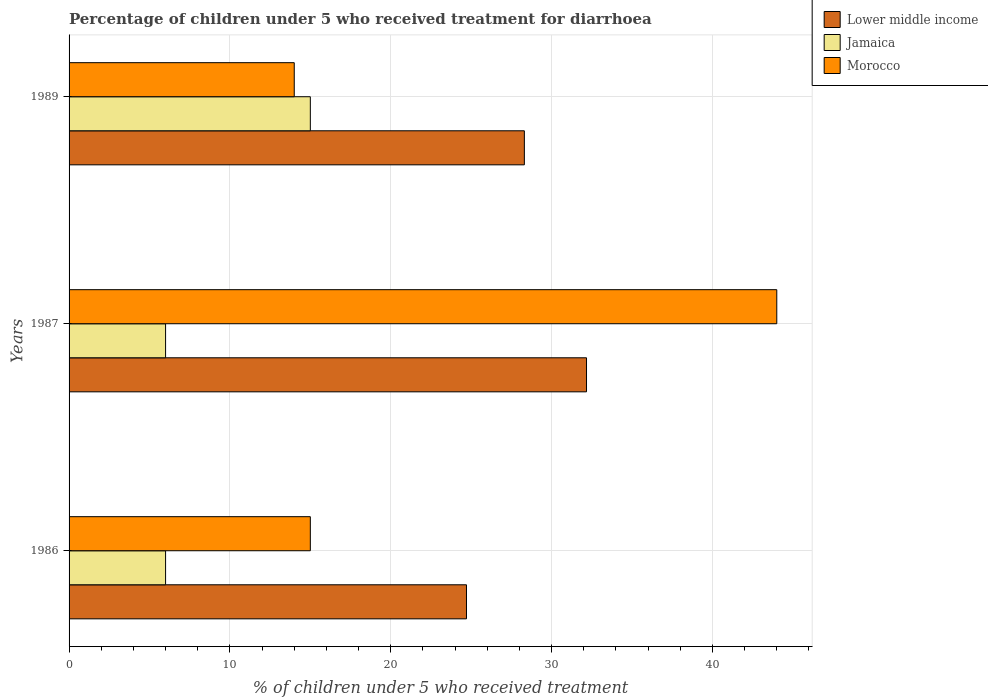How many different coloured bars are there?
Give a very brief answer. 3. How many groups of bars are there?
Provide a short and direct response. 3. Are the number of bars per tick equal to the number of legend labels?
Your answer should be compact. Yes. How many bars are there on the 1st tick from the top?
Provide a short and direct response. 3. In how many cases, is the number of bars for a given year not equal to the number of legend labels?
Offer a very short reply. 0. Across all years, what is the minimum percentage of children who received treatment for diarrhoea  in Morocco?
Your response must be concise. 14. In which year was the percentage of children who received treatment for diarrhoea  in Jamaica maximum?
Give a very brief answer. 1989. What is the total percentage of children who received treatment for diarrhoea  in Lower middle income in the graph?
Ensure brevity in your answer.  85.19. What is the difference between the percentage of children who received treatment for diarrhoea  in Jamaica in 1986 and that in 1987?
Ensure brevity in your answer.  0. What is the difference between the percentage of children who received treatment for diarrhoea  in Jamaica in 1987 and the percentage of children who received treatment for diarrhoea  in Lower middle income in 1989?
Provide a succinct answer. -22.31. What is the average percentage of children who received treatment for diarrhoea  in Lower middle income per year?
Keep it short and to the point. 28.4. In the year 1986, what is the difference between the percentage of children who received treatment for diarrhoea  in Lower middle income and percentage of children who received treatment for diarrhoea  in Morocco?
Offer a very short reply. 9.71. What is the ratio of the percentage of children who received treatment for diarrhoea  in Lower middle income in 1987 to that in 1989?
Your answer should be compact. 1.14. Is the percentage of children who received treatment for diarrhoea  in Lower middle income in 1987 less than that in 1989?
Make the answer very short. No. Is the difference between the percentage of children who received treatment for diarrhoea  in Lower middle income in 1986 and 1987 greater than the difference between the percentage of children who received treatment for diarrhoea  in Morocco in 1986 and 1987?
Provide a succinct answer. Yes. What is the difference between the highest and the second highest percentage of children who received treatment for diarrhoea  in Lower middle income?
Provide a succinct answer. 3.86. What is the difference between the highest and the lowest percentage of children who received treatment for diarrhoea  in Lower middle income?
Make the answer very short. 7.46. In how many years, is the percentage of children who received treatment for diarrhoea  in Lower middle income greater than the average percentage of children who received treatment for diarrhoea  in Lower middle income taken over all years?
Ensure brevity in your answer.  1. What does the 3rd bar from the top in 1989 represents?
Your answer should be compact. Lower middle income. What does the 1st bar from the bottom in 1986 represents?
Your response must be concise. Lower middle income. Is it the case that in every year, the sum of the percentage of children who received treatment for diarrhoea  in Lower middle income and percentage of children who received treatment for diarrhoea  in Jamaica is greater than the percentage of children who received treatment for diarrhoea  in Morocco?
Offer a very short reply. No. How many bars are there?
Offer a very short reply. 9. What is the difference between two consecutive major ticks on the X-axis?
Your answer should be compact. 10. Does the graph contain any zero values?
Offer a terse response. No. Does the graph contain grids?
Give a very brief answer. Yes. What is the title of the graph?
Keep it short and to the point. Percentage of children under 5 who received treatment for diarrhoea. What is the label or title of the X-axis?
Provide a succinct answer. % of children under 5 who received treatment. What is the % of children under 5 who received treatment of Lower middle income in 1986?
Your answer should be very brief. 24.71. What is the % of children under 5 who received treatment in Jamaica in 1986?
Give a very brief answer. 6. What is the % of children under 5 who received treatment of Lower middle income in 1987?
Your response must be concise. 32.17. What is the % of children under 5 who received treatment in Jamaica in 1987?
Your response must be concise. 6. What is the % of children under 5 who received treatment in Lower middle income in 1989?
Make the answer very short. 28.31. What is the % of children under 5 who received treatment of Morocco in 1989?
Your answer should be compact. 14. Across all years, what is the maximum % of children under 5 who received treatment of Lower middle income?
Your answer should be very brief. 32.17. Across all years, what is the maximum % of children under 5 who received treatment in Jamaica?
Your answer should be compact. 15. Across all years, what is the minimum % of children under 5 who received treatment of Lower middle income?
Give a very brief answer. 24.71. What is the total % of children under 5 who received treatment of Lower middle income in the graph?
Offer a terse response. 85.19. What is the total % of children under 5 who received treatment of Jamaica in the graph?
Your response must be concise. 27. What is the total % of children under 5 who received treatment in Morocco in the graph?
Your answer should be compact. 73. What is the difference between the % of children under 5 who received treatment of Lower middle income in 1986 and that in 1987?
Your answer should be very brief. -7.46. What is the difference between the % of children under 5 who received treatment in Lower middle income in 1986 and that in 1989?
Your response must be concise. -3.6. What is the difference between the % of children under 5 who received treatment in Morocco in 1986 and that in 1989?
Your response must be concise. 1. What is the difference between the % of children under 5 who received treatment of Lower middle income in 1987 and that in 1989?
Ensure brevity in your answer.  3.86. What is the difference between the % of children under 5 who received treatment of Morocco in 1987 and that in 1989?
Provide a short and direct response. 30. What is the difference between the % of children under 5 who received treatment of Lower middle income in 1986 and the % of children under 5 who received treatment of Jamaica in 1987?
Keep it short and to the point. 18.71. What is the difference between the % of children under 5 who received treatment in Lower middle income in 1986 and the % of children under 5 who received treatment in Morocco in 1987?
Offer a very short reply. -19.29. What is the difference between the % of children under 5 who received treatment in Jamaica in 1986 and the % of children under 5 who received treatment in Morocco in 1987?
Keep it short and to the point. -38. What is the difference between the % of children under 5 who received treatment in Lower middle income in 1986 and the % of children under 5 who received treatment in Jamaica in 1989?
Make the answer very short. 9.71. What is the difference between the % of children under 5 who received treatment of Lower middle income in 1986 and the % of children under 5 who received treatment of Morocco in 1989?
Provide a succinct answer. 10.71. What is the difference between the % of children under 5 who received treatment in Jamaica in 1986 and the % of children under 5 who received treatment in Morocco in 1989?
Offer a very short reply. -8. What is the difference between the % of children under 5 who received treatment of Lower middle income in 1987 and the % of children under 5 who received treatment of Jamaica in 1989?
Give a very brief answer. 17.17. What is the difference between the % of children under 5 who received treatment of Lower middle income in 1987 and the % of children under 5 who received treatment of Morocco in 1989?
Offer a very short reply. 18.17. What is the average % of children under 5 who received treatment in Lower middle income per year?
Your answer should be very brief. 28.4. What is the average % of children under 5 who received treatment of Morocco per year?
Your answer should be very brief. 24.33. In the year 1986, what is the difference between the % of children under 5 who received treatment of Lower middle income and % of children under 5 who received treatment of Jamaica?
Your answer should be very brief. 18.71. In the year 1986, what is the difference between the % of children under 5 who received treatment of Lower middle income and % of children under 5 who received treatment of Morocco?
Ensure brevity in your answer.  9.71. In the year 1986, what is the difference between the % of children under 5 who received treatment in Jamaica and % of children under 5 who received treatment in Morocco?
Your answer should be very brief. -9. In the year 1987, what is the difference between the % of children under 5 who received treatment in Lower middle income and % of children under 5 who received treatment in Jamaica?
Ensure brevity in your answer.  26.17. In the year 1987, what is the difference between the % of children under 5 who received treatment in Lower middle income and % of children under 5 who received treatment in Morocco?
Provide a short and direct response. -11.83. In the year 1987, what is the difference between the % of children under 5 who received treatment of Jamaica and % of children under 5 who received treatment of Morocco?
Provide a short and direct response. -38. In the year 1989, what is the difference between the % of children under 5 who received treatment of Lower middle income and % of children under 5 who received treatment of Jamaica?
Offer a terse response. 13.31. In the year 1989, what is the difference between the % of children under 5 who received treatment of Lower middle income and % of children under 5 who received treatment of Morocco?
Your response must be concise. 14.31. In the year 1989, what is the difference between the % of children under 5 who received treatment in Jamaica and % of children under 5 who received treatment in Morocco?
Offer a very short reply. 1. What is the ratio of the % of children under 5 who received treatment of Lower middle income in 1986 to that in 1987?
Your answer should be very brief. 0.77. What is the ratio of the % of children under 5 who received treatment of Morocco in 1986 to that in 1987?
Give a very brief answer. 0.34. What is the ratio of the % of children under 5 who received treatment in Lower middle income in 1986 to that in 1989?
Your answer should be very brief. 0.87. What is the ratio of the % of children under 5 who received treatment of Jamaica in 1986 to that in 1989?
Give a very brief answer. 0.4. What is the ratio of the % of children under 5 who received treatment in Morocco in 1986 to that in 1989?
Offer a terse response. 1.07. What is the ratio of the % of children under 5 who received treatment of Lower middle income in 1987 to that in 1989?
Provide a short and direct response. 1.14. What is the ratio of the % of children under 5 who received treatment of Morocco in 1987 to that in 1989?
Offer a very short reply. 3.14. What is the difference between the highest and the second highest % of children under 5 who received treatment of Lower middle income?
Provide a succinct answer. 3.86. What is the difference between the highest and the second highest % of children under 5 who received treatment of Morocco?
Your answer should be very brief. 29. What is the difference between the highest and the lowest % of children under 5 who received treatment in Lower middle income?
Your answer should be compact. 7.46. What is the difference between the highest and the lowest % of children under 5 who received treatment of Morocco?
Your answer should be compact. 30. 